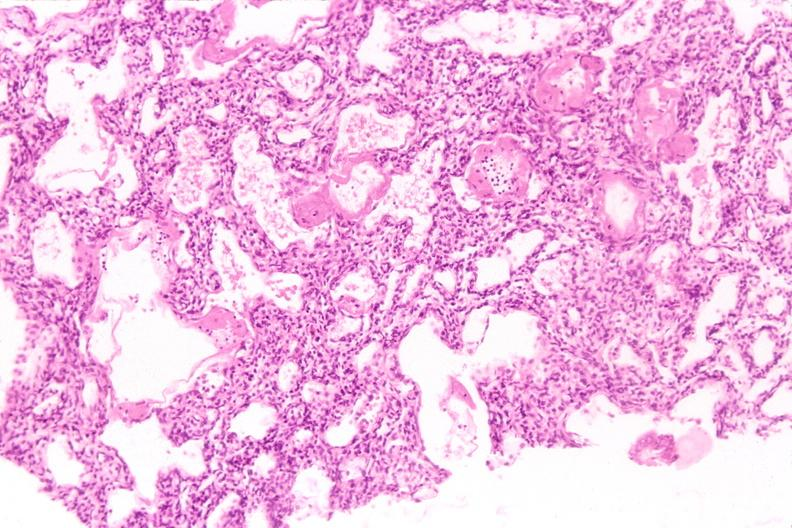s liver present?
Answer the question using a single word or phrase. No 